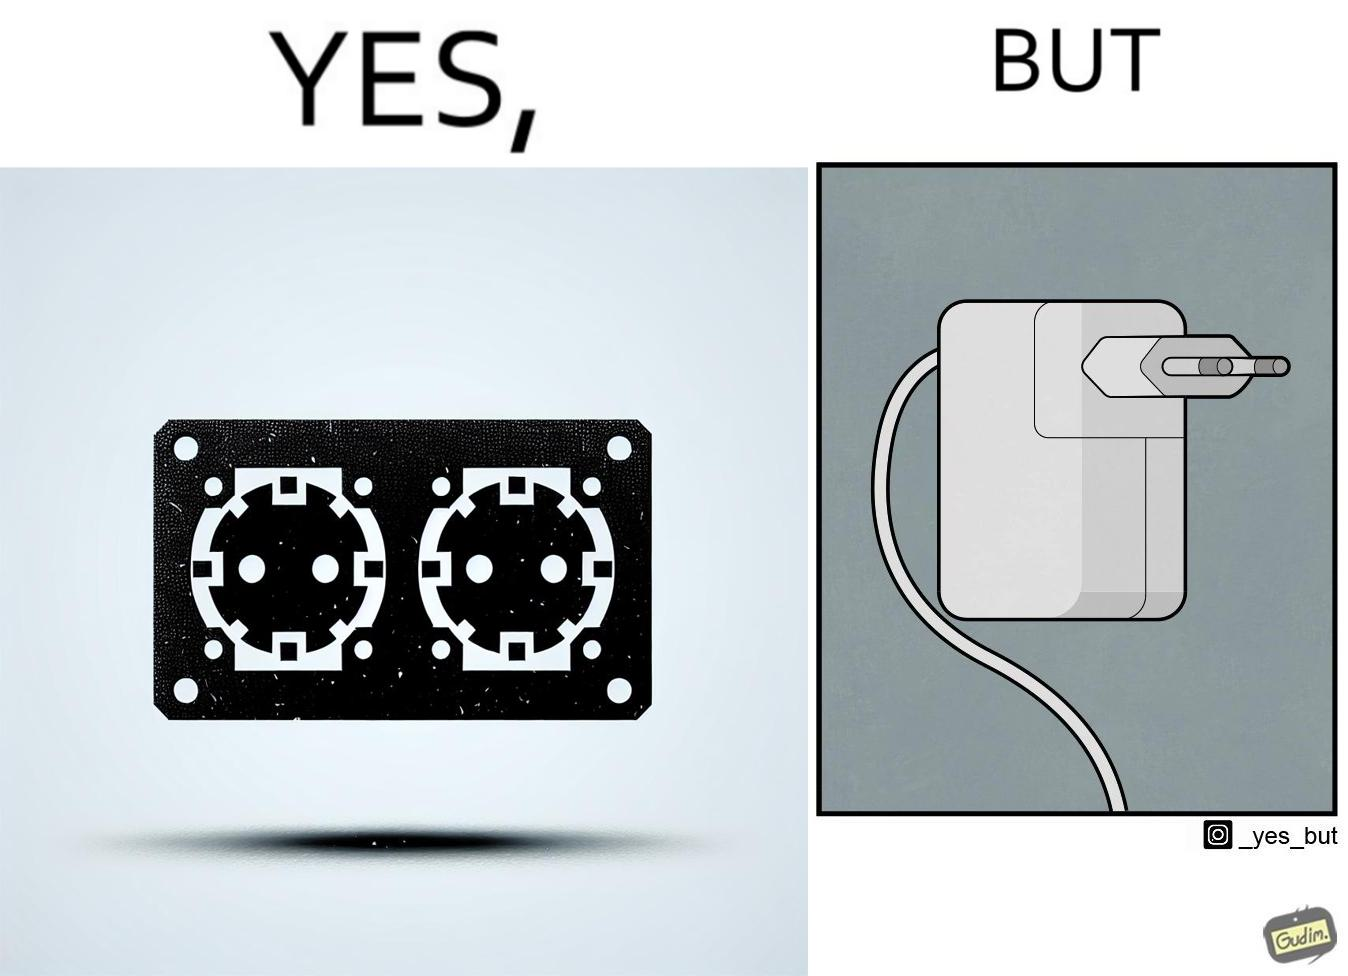Why is this image considered satirical? The image is funny, as there are two electrical sockets side-by-side, but the adapter is shaped in such a way, that if two adapters are inserted into the two sockets, they will butt into each other, leading to inconvenience. 